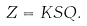<formula> <loc_0><loc_0><loc_500><loc_500>Z = K S Q .</formula> 